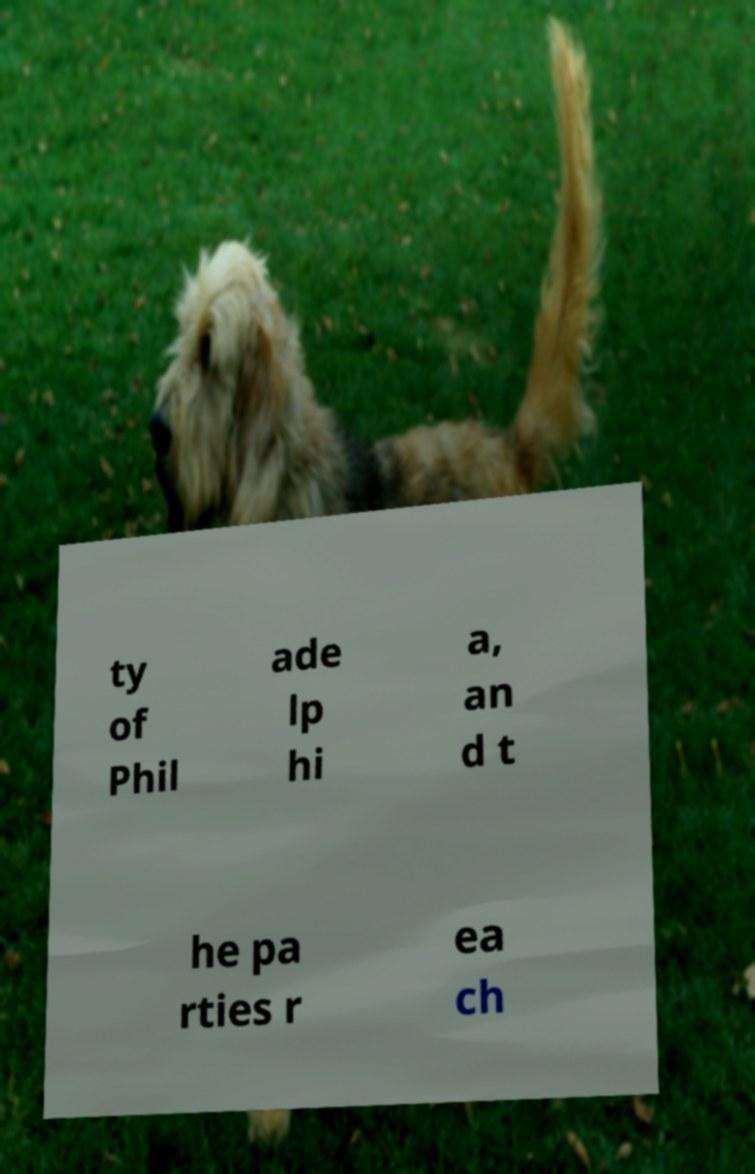Can you accurately transcribe the text from the provided image for me? ty of Phil ade lp hi a, an d t he pa rties r ea ch 